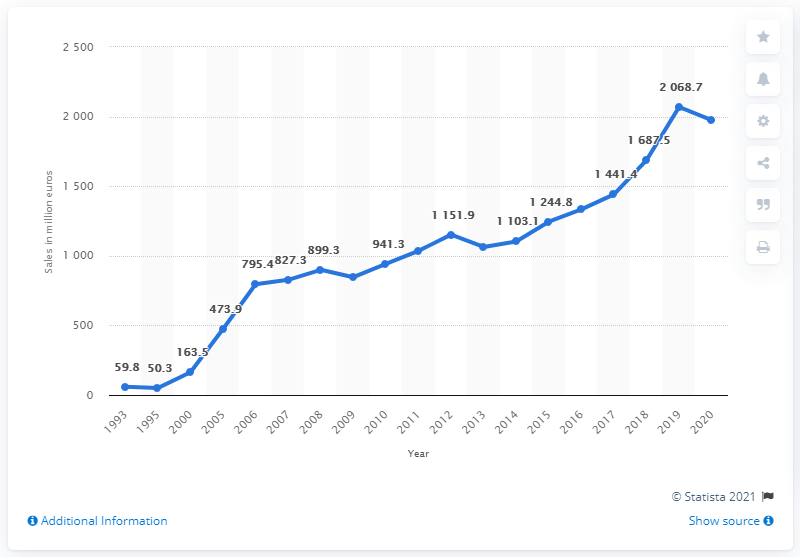Point out several critical features in this image. The sales of Puma apparel in 2020 were 1974.1. 